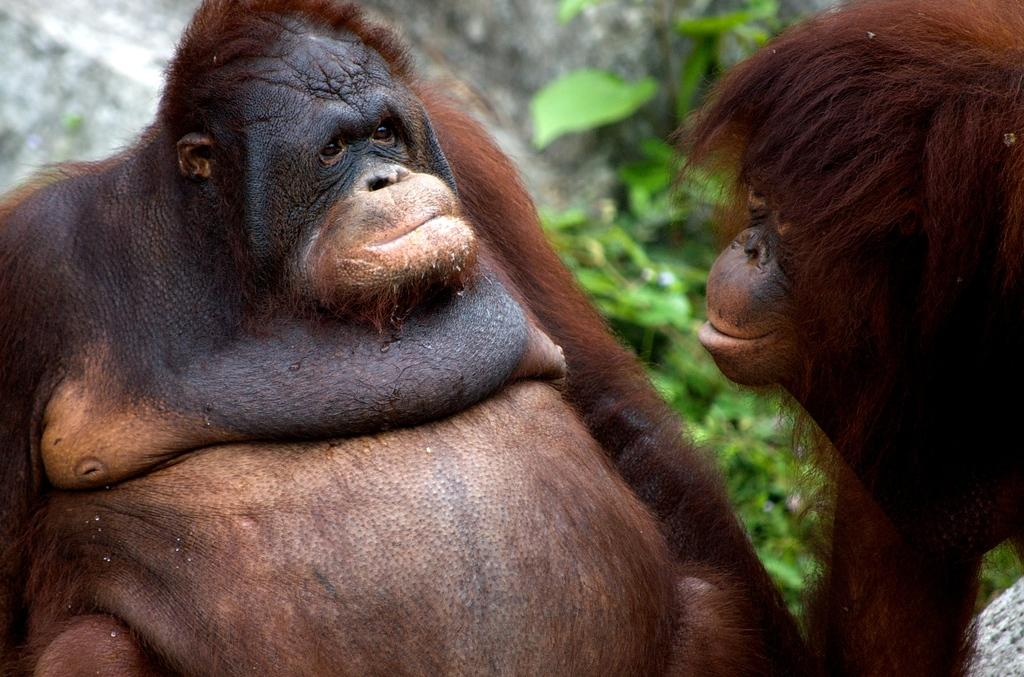What type of animals are in the image? There are chimpanzees in the image. What type of vegetation can be seen in the background of the image? There is grass visible in the background of the image. What type of legal advice can be seen being given to the chimpanzees in the image? There is no lawyer or legal advice present in the image; it features chimpanzees and grass. What type of power source can be seen in the image? There is no power source present in the image; it features chimpanzees and grass. 